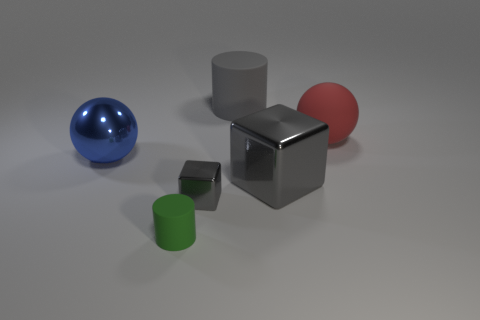There is a large rubber thing that is behind the red matte thing; what shape is it? cylinder 